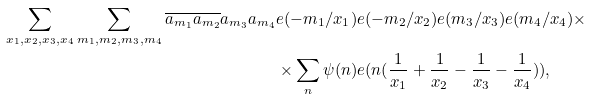<formula> <loc_0><loc_0><loc_500><loc_500>\sum _ { x _ { 1 } , x _ { 2 } , x _ { 3 } , x _ { 4 } } \sum _ { m _ { 1 } , m _ { 2 } , m _ { 3 } , m _ { 4 } } \overline { a _ { m _ { 1 } } a _ { m _ { 2 } } } a _ { m _ { 3 } } a _ { m _ { 4 } } & e ( - m _ { 1 } / x _ { 1 } ) e ( - m _ { 2 } / x _ { 2 } ) e ( m _ { 3 } / x _ { 3 } ) e ( m _ { 4 } / x _ { 4 } ) \times \\ & \times \sum _ { n } \psi ( n ) e ( n ( \frac { 1 } { x _ { 1 } } + \frac { 1 } { x _ { 2 } } - \frac { 1 } { x _ { 3 } } - \frac { 1 } { x _ { 4 } } ) ) ,</formula> 